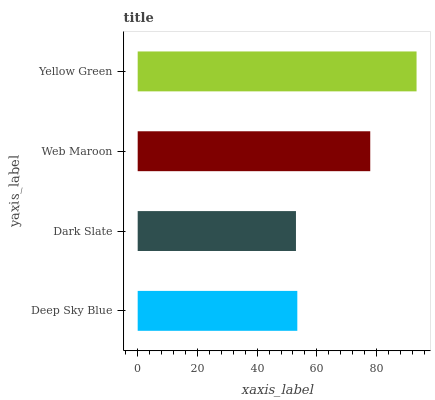Is Dark Slate the minimum?
Answer yes or no. Yes. Is Yellow Green the maximum?
Answer yes or no. Yes. Is Web Maroon the minimum?
Answer yes or no. No. Is Web Maroon the maximum?
Answer yes or no. No. Is Web Maroon greater than Dark Slate?
Answer yes or no. Yes. Is Dark Slate less than Web Maroon?
Answer yes or no. Yes. Is Dark Slate greater than Web Maroon?
Answer yes or no. No. Is Web Maroon less than Dark Slate?
Answer yes or no. No. Is Web Maroon the high median?
Answer yes or no. Yes. Is Deep Sky Blue the low median?
Answer yes or no. Yes. Is Deep Sky Blue the high median?
Answer yes or no. No. Is Web Maroon the low median?
Answer yes or no. No. 